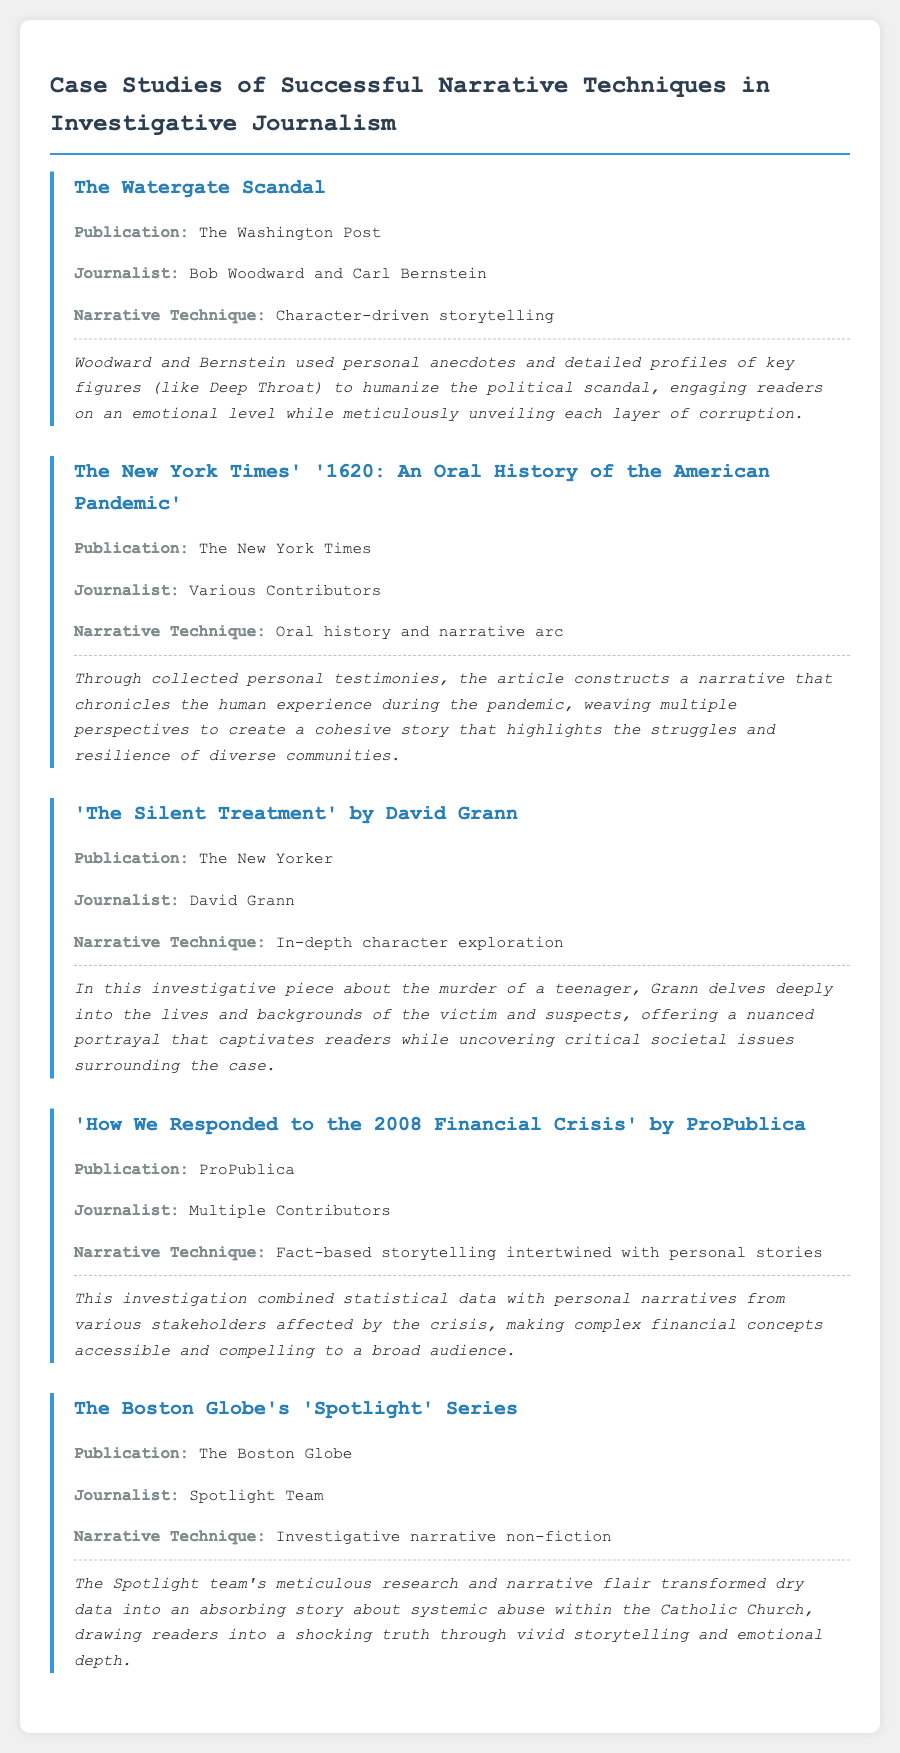What is the first case study mentioned? The first case study is listed under the title "The Watergate Scandal" in the document.
Answer: The Watergate Scandal Who are the journalists for the Watergate case study? The document specifies Bob Woodward and Carl Bernstein as the journalists involved in the Watergate case study.
Answer: Bob Woodward and Carl Bernstein What narrative technique is used in "The Silent Treatment"? The document states that the narrative technique employed in "The Silent Treatment" is in-depth character exploration.
Answer: In-depth character exploration How many contributors worked on the New York Times article "1620: An Oral History of the American Pandemic"? The exact number of contributors is not specified, only that there were various contributors mentioned in the document.
Answer: Various Contributors What is the publication for the Spotlight series? The document states that the Spotlight series was published by The Boston Globe.
Answer: The Boston Globe Which narrative technique combines statistical data with personal narratives? In the document, the narrative technique that combines statistical data with personal stories is used in "How We Responded to the 2008 Financial Crisis."
Answer: Fact-based storytelling intertwined with personal stories What type of journalism is exemplified by the investigation of systemic abuse within the Catholic Church? The document classifies the investigation of systemic abuse within the Catholic Church as investigative narrative non-fiction.
Answer: Investigative narrative non-fiction Who authored "The Silent Treatment"? The document attributes the authorship of "The Silent Treatment" to David Grann.
Answer: David Grann What publication featured "The New York Times' '1620: An Oral History of the American Pandemic'"? According to the document, this case study was featured in The New York Times.
Answer: The New York Times 